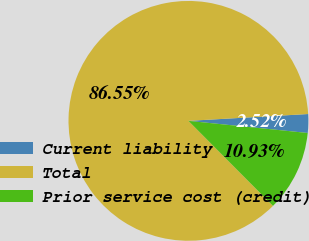<chart> <loc_0><loc_0><loc_500><loc_500><pie_chart><fcel>Current liability<fcel>Total<fcel>Prior service cost (credit)<nl><fcel>2.52%<fcel>86.55%<fcel>10.93%<nl></chart> 